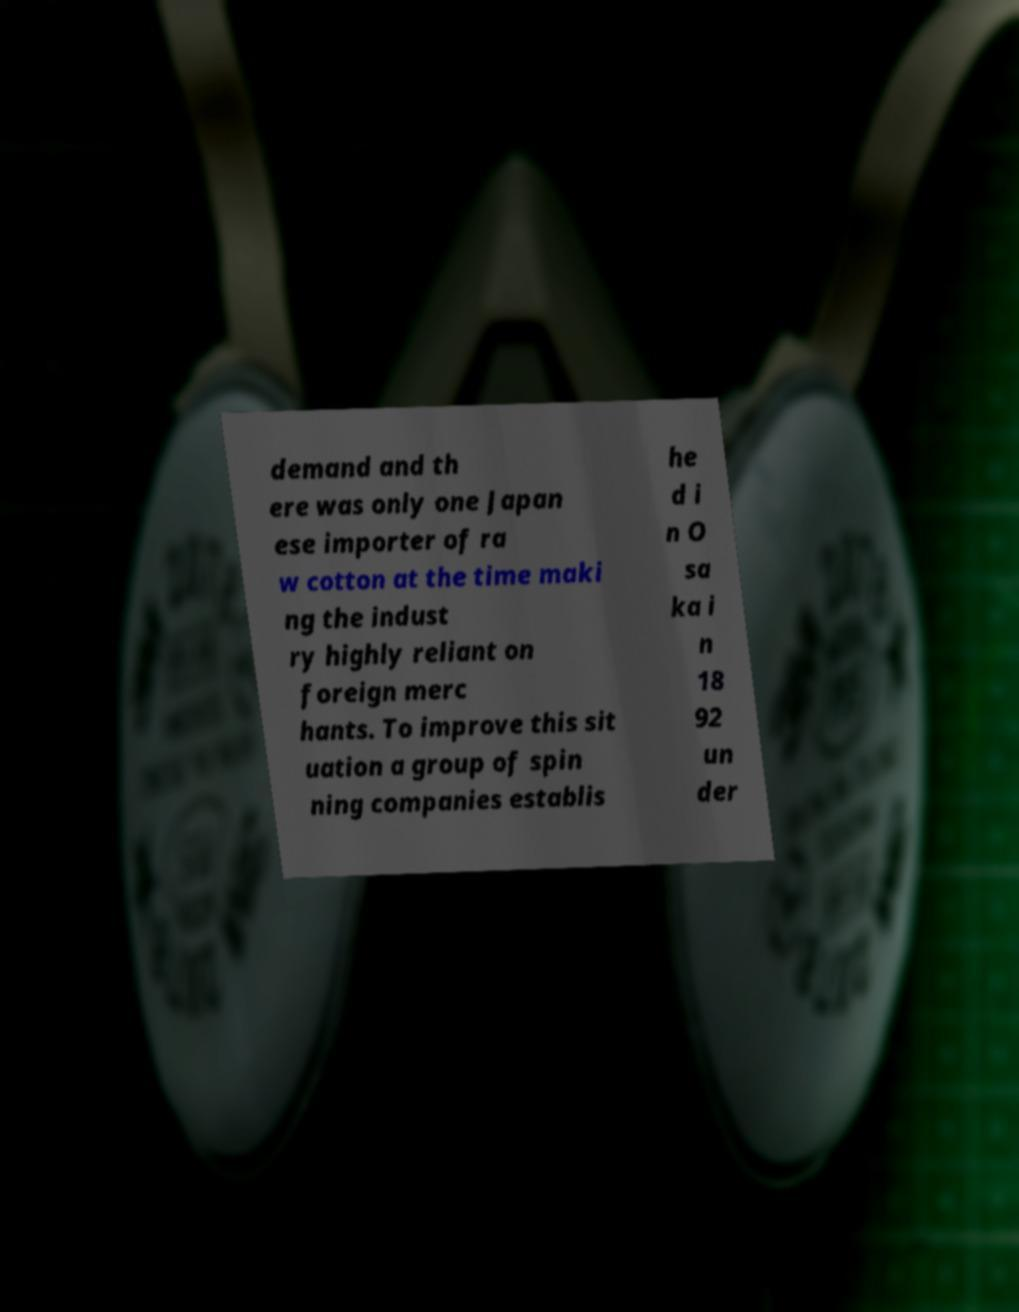I need the written content from this picture converted into text. Can you do that? demand and th ere was only one Japan ese importer of ra w cotton at the time maki ng the indust ry highly reliant on foreign merc hants. To improve this sit uation a group of spin ning companies establis he d i n O sa ka i n 18 92 un der 